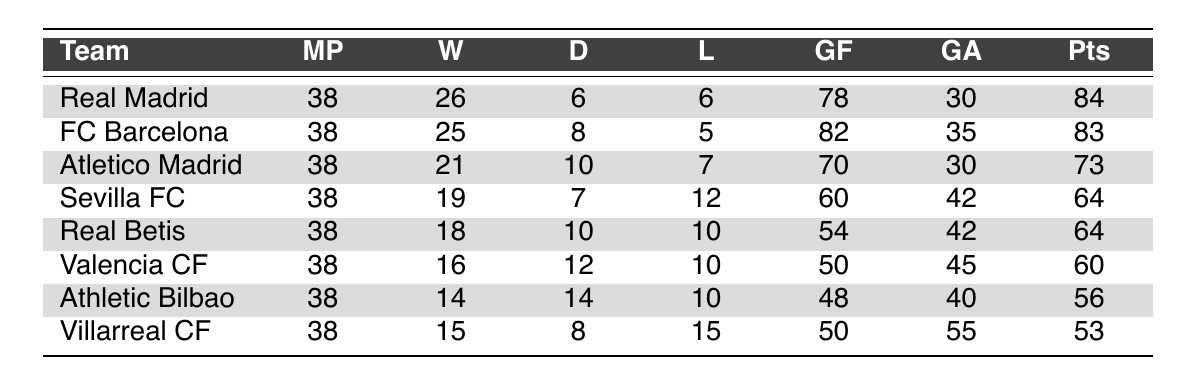What team had the highest number of wins? By examining the "Wins" column, Real Madrid has 26 wins, which is the highest among all teams.
Answer: Real Madrid What is the total number of goals scored by FC Barcelona and Atletico Madrid? FC Barcelona scored 82 goals and Atletico Madrid scored 70 goals. Adding these gives 82 + 70 = 152 goals.
Answer: 152 Which team finished with the lowest number of points? By looking at the "Points" column, Villarreal CF has the lowest points at 53.
Answer: Villarreal CF Did Sevilla FC win more matches than Valencia CF? Sevilla FC won 19 matches while Valencia CF won 16 matches. Since 19 is greater than 16, the statement is true.
Answer: Yes What is the difference in goals against between Real Madrid and Real Betis? Real Madrid had 30 goals against, while Real Betis had 42. The difference is 42 - 30 = 12 goals against.
Answer: 12 What is the average number of points for the teams listed? The total points are 84 + 83 + 73 + 64 + 64 + 60 + 56 + 53 = 537 points. There are 8 teams, so the average is 537 / 8 = 67.125, which can be rounded to 67.
Answer: 67 Which teams have the same number of points, and how many points do they have? Sevilla FC and Real Betis both have 64 points.
Answer: 64 points If Atletico Madrid had won one more match, how many points would they have? If Atletico Madrid had one more win, they would have 21 + 1 = 22 wins. The points for a win are 3, so 22 wins would give them 22 * 3 = 66 points.
Answer: 66 What percentage of matches did Valencia CF end in draws? Valencia CF had 12 draws out of 38 matches. The percentage is (12 / 38) * 100 = 31.58%, which can be rounded to 32%.
Answer: 32% Which team had the highest goal difference? To find the goal difference, subtract "Goals Against" from "Goals For" for each team. Real Madrid has a goal difference of 78 - 30 = 48, which is the highest.
Answer: Real Madrid 